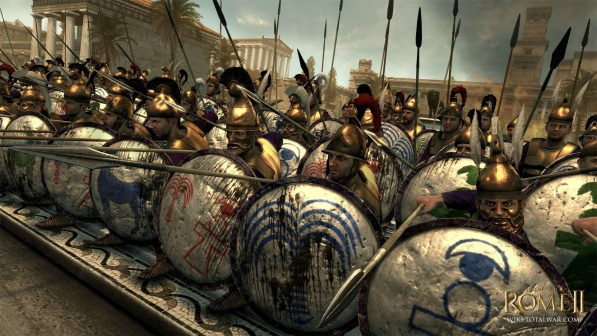What historical period does this image likely represent, and how can we determine that from the soldiers' armor and weapons? This image likely portrays a period in ancient Rome, possibly during the late Republic or early Empire phases, characterized by the use of the scutum, a large rectangular shield, and the galea helmet with its distinctive plume. The soldiers' armor, including lorica segmentata (segmented plate armor), was common in the Roman legions during these periods. The formation displayed, a tight phalanx, was a common tactical formation which emphasizes the era's focus on disciplined, coordinated combat strategies. 